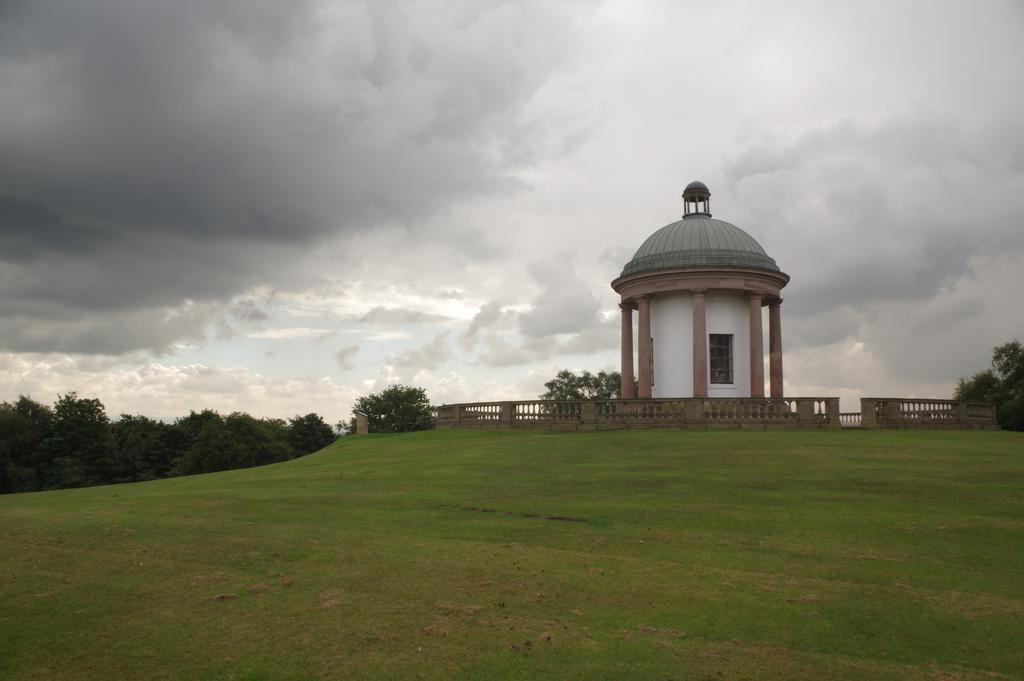Please provide a concise description of this image. In this image I can see the ground, some grass on the ground, few trees which are green in color, the railing and a building which is white, brown and green in color. In the background I can see the sky. 